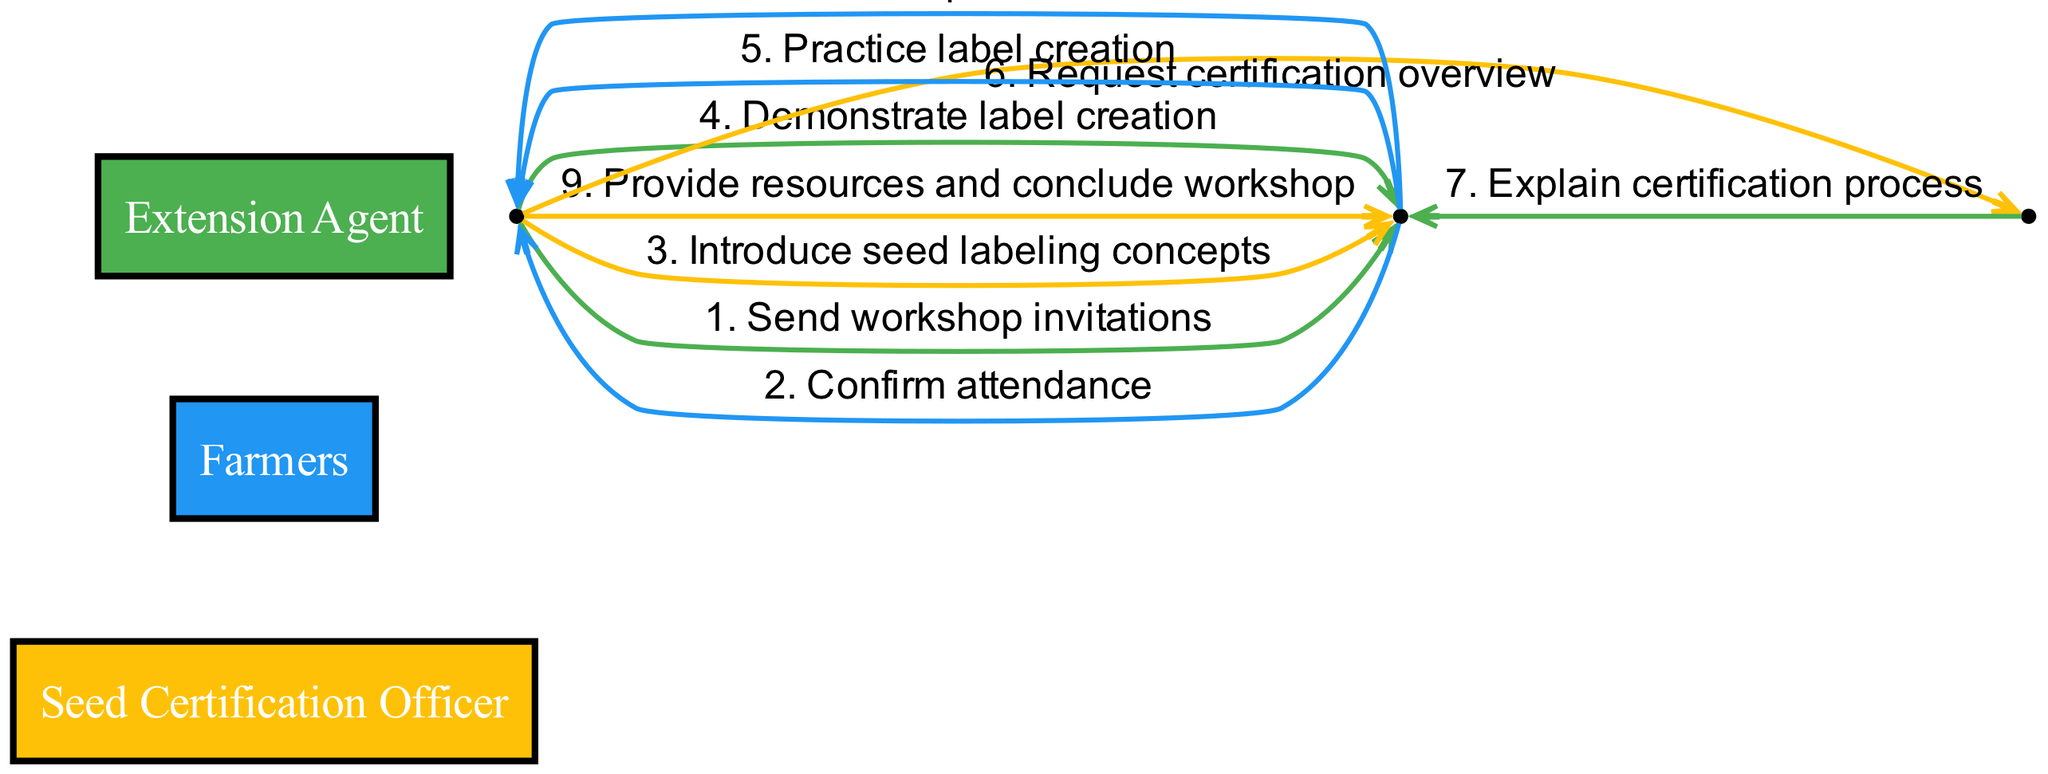What is the first action taken in the workshop sequence? The first action in the sequence is initiated by the Extension Agent who sends workshop invitations to the farmers. This is depicted as the first arrow leading out from the Extension Agent.
Answer: Send workshop invitations How many actors are involved in the sequence diagram? The sequence diagram features three distinct actors: the Extension Agent, Farmers, and the Seed Certification Officer. This is verified by counting the different actor nodes in the diagram.
Answer: Three Who explains the certification process to the farmers? The explanation of the certification process is provided by the Seed Certification Officer, as shown in the sequence where the farmers receive this information directly from them.
Answer: Seed Certification Officer What action ends the workshop sequence? The final action in the sequence is taken by the Extension Agent, who provides resources and concludes the workshop. This is represented as the last arrow leading to the farmers.
Answer: Provide resources and conclude workshop How many total actions are depicted in the sequence? The sequence diagram contains a total of 9 actions, as indicated by the number of distinct arrows connecting the actors in the workflow. Each action is labeled sequentially.
Answer: Nine Which actor practices label creation during the workshop? The action of practicing label creation is initiated by the farmers in response to the demonstration given by the Extension Agent. This shows farmers actively engaging in the learning process.
Answer: Farmers What is the relationship between the Extension Agent and the Seed Certification Officer? The relationship between these two actors is that the Extension Agent requests an overview of the certification process from the Seed Certification Officer. This shows a communicative flow where one actor seeks information from the other.
Answer: Request certification overview During what stage do farmers ask questions? The stage where farmers ask questions occurs after the Seed Certification Officer explains the certification process. This sequence reflects the interactive nature of the workshop, allowing farmers to engage further.
Answer: Ask questions What is the purpose of the actions directed toward farmers? The actions directed toward farmers are primarily educational, aimed at introducing seed labeling concepts and skills such as creating labels, along with explaining the certification process. This reflects the workshop's goal of informing the farmers.
Answer: Educational 